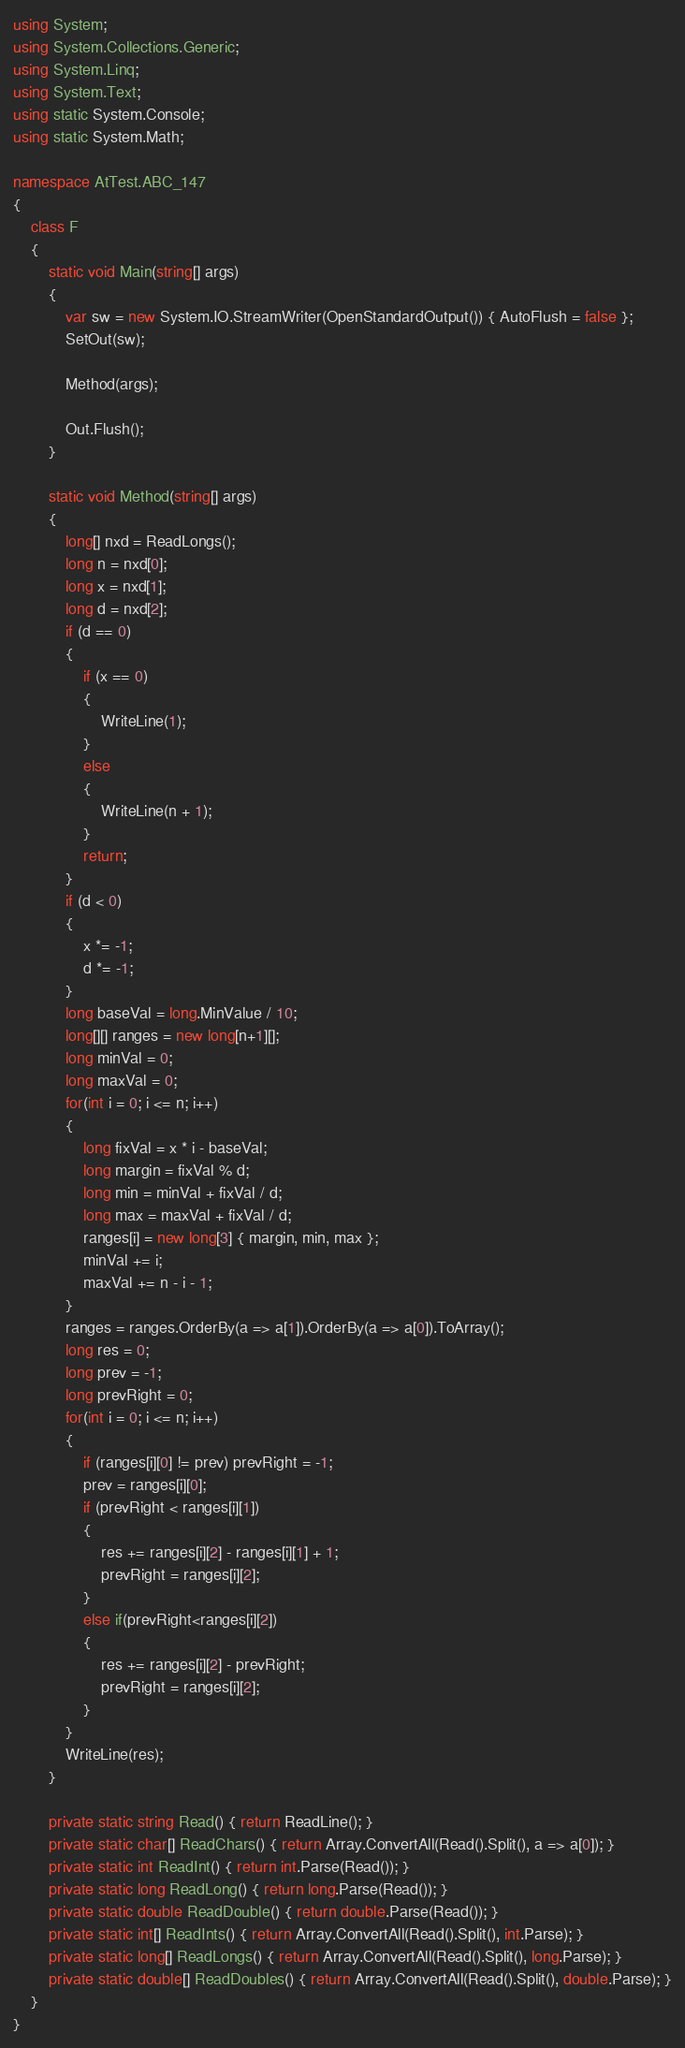Convert code to text. <code><loc_0><loc_0><loc_500><loc_500><_C#_>using System;
using System.Collections.Generic;
using System.Linq;
using System.Text;
using static System.Console;
using static System.Math;

namespace AtTest.ABC_147
{
    class F
    {
        static void Main(string[] args)
        {
            var sw = new System.IO.StreamWriter(OpenStandardOutput()) { AutoFlush = false };
            SetOut(sw);

            Method(args);

            Out.Flush();
        }

        static void Method(string[] args)
        {
            long[] nxd = ReadLongs();
            long n = nxd[0];
            long x = nxd[1];
            long d = nxd[2];
            if (d == 0)
            {
                if (x == 0)
                {
                    WriteLine(1);
                }
                else
                {
                    WriteLine(n + 1);
                }
                return;
            }
            if (d < 0)
            {
                x *= -1;
                d *= -1;
            }
            long baseVal = long.MinValue / 10;
            long[][] ranges = new long[n+1][];
            long minVal = 0;
            long maxVal = 0;
            for(int i = 0; i <= n; i++)
            {
                long fixVal = x * i - baseVal;
                long margin = fixVal % d;
                long min = minVal + fixVal / d;
                long max = maxVal + fixVal / d;
                ranges[i] = new long[3] { margin, min, max };
                minVal += i;
                maxVal += n - i - 1;
            }
            ranges = ranges.OrderBy(a => a[1]).OrderBy(a => a[0]).ToArray();
            long res = 0;
            long prev = -1;
            long prevRight = 0;
            for(int i = 0; i <= n; i++)
            {
                if (ranges[i][0] != prev) prevRight = -1;
                prev = ranges[i][0];
                if (prevRight < ranges[i][1])
                {
                    res += ranges[i][2] - ranges[i][1] + 1;
                    prevRight = ranges[i][2];
                }
                else if(prevRight<ranges[i][2])
                {
                    res += ranges[i][2] - prevRight;
                    prevRight = ranges[i][2];
                }
            }
            WriteLine(res);
        }

        private static string Read() { return ReadLine(); }
        private static char[] ReadChars() { return Array.ConvertAll(Read().Split(), a => a[0]); }
        private static int ReadInt() { return int.Parse(Read()); }
        private static long ReadLong() { return long.Parse(Read()); }
        private static double ReadDouble() { return double.Parse(Read()); }
        private static int[] ReadInts() { return Array.ConvertAll(Read().Split(), int.Parse); }
        private static long[] ReadLongs() { return Array.ConvertAll(Read().Split(), long.Parse); }
        private static double[] ReadDoubles() { return Array.ConvertAll(Read().Split(), double.Parse); }
    }
}
</code> 